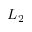<formula> <loc_0><loc_0><loc_500><loc_500>L _ { 2 }</formula> 